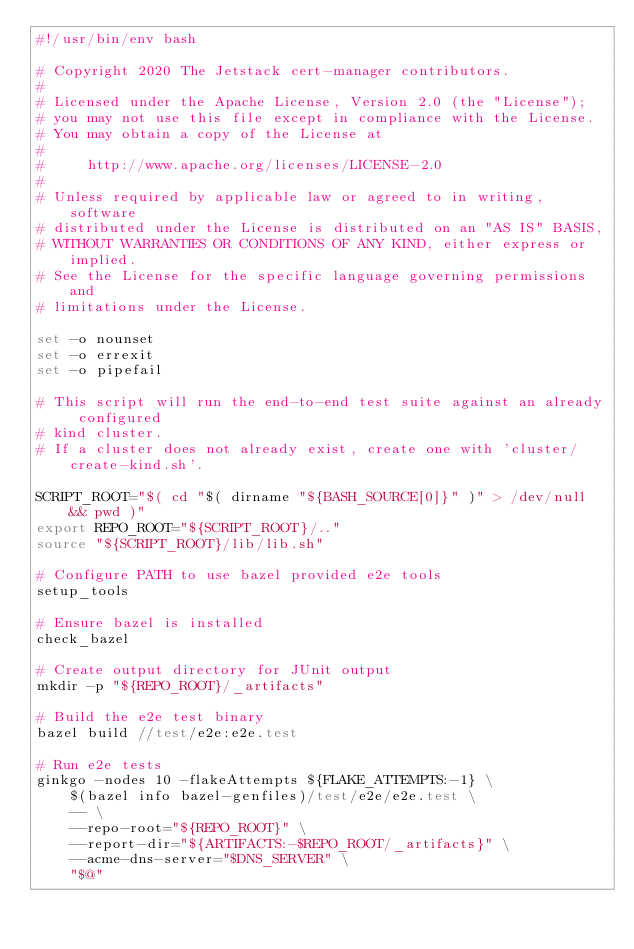<code> <loc_0><loc_0><loc_500><loc_500><_Bash_>#!/usr/bin/env bash

# Copyright 2020 The Jetstack cert-manager contributors.
#
# Licensed under the Apache License, Version 2.0 (the "License");
# you may not use this file except in compliance with the License.
# You may obtain a copy of the License at
#
#     http://www.apache.org/licenses/LICENSE-2.0
#
# Unless required by applicable law or agreed to in writing, software
# distributed under the License is distributed on an "AS IS" BASIS,
# WITHOUT WARRANTIES OR CONDITIONS OF ANY KIND, either express or implied.
# See the License for the specific language governing permissions and
# limitations under the License.

set -o nounset
set -o errexit
set -o pipefail

# This script will run the end-to-end test suite against an already configured
# kind cluster.
# If a cluster does not already exist, create one with 'cluster/create-kind.sh'.

SCRIPT_ROOT="$( cd "$( dirname "${BASH_SOURCE[0]}" )" > /dev/null && pwd )"
export REPO_ROOT="${SCRIPT_ROOT}/.."
source "${SCRIPT_ROOT}/lib/lib.sh"

# Configure PATH to use bazel provided e2e tools
setup_tools

# Ensure bazel is installed
check_bazel

# Create output directory for JUnit output
mkdir -p "${REPO_ROOT}/_artifacts"

# Build the e2e test binary
bazel build //test/e2e:e2e.test

# Run e2e tests
ginkgo -nodes 10 -flakeAttempts ${FLAKE_ATTEMPTS:-1} \
	$(bazel info bazel-genfiles)/test/e2e/e2e.test \
	-- \
	--repo-root="${REPO_ROOT}" \
	--report-dir="${ARTIFACTS:-$REPO_ROOT/_artifacts}" \
	--acme-dns-server="$DNS_SERVER" \
	"$@"
</code> 